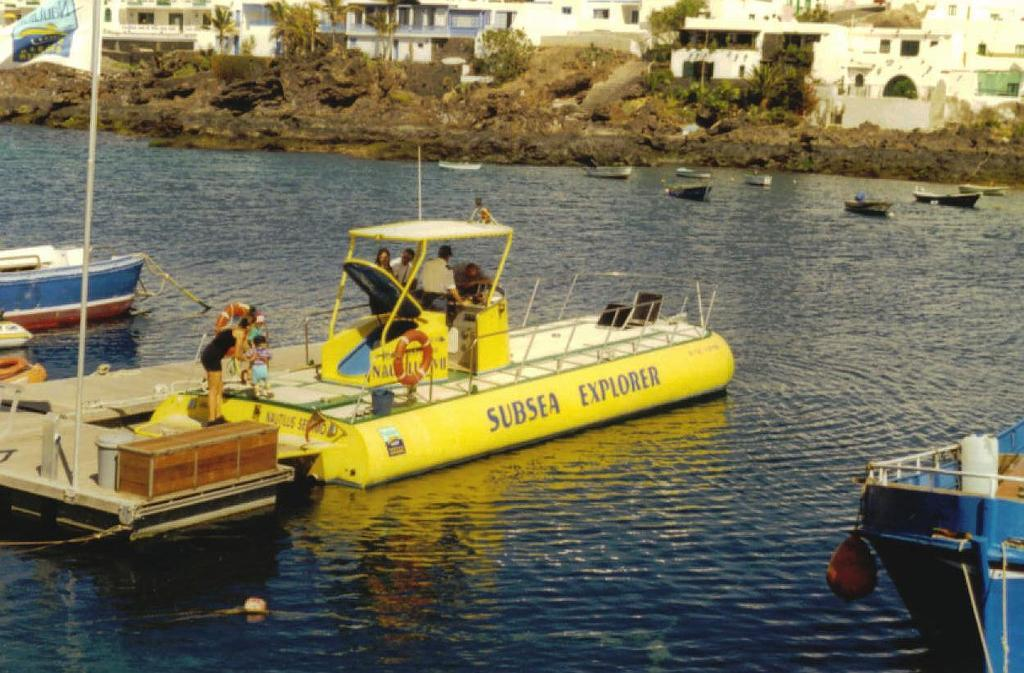What is on the water in the image? There are boats on the water in the image. What type of natural vegetation can be seen in the image? There are trees visible in the image. Who or what is present in the image? There are people present in the image. What type of structures can be seen in the image? There are buildings in the image. What architectural feature is visible in the image? There are windows visible in the image. What symbol can be seen in the image? There is a flag in the image. What type of hair can be seen on the tree in the image? There is no tree with hair present in the image. What type of queen is depicted in the image? There is no queen depicted in the image. 